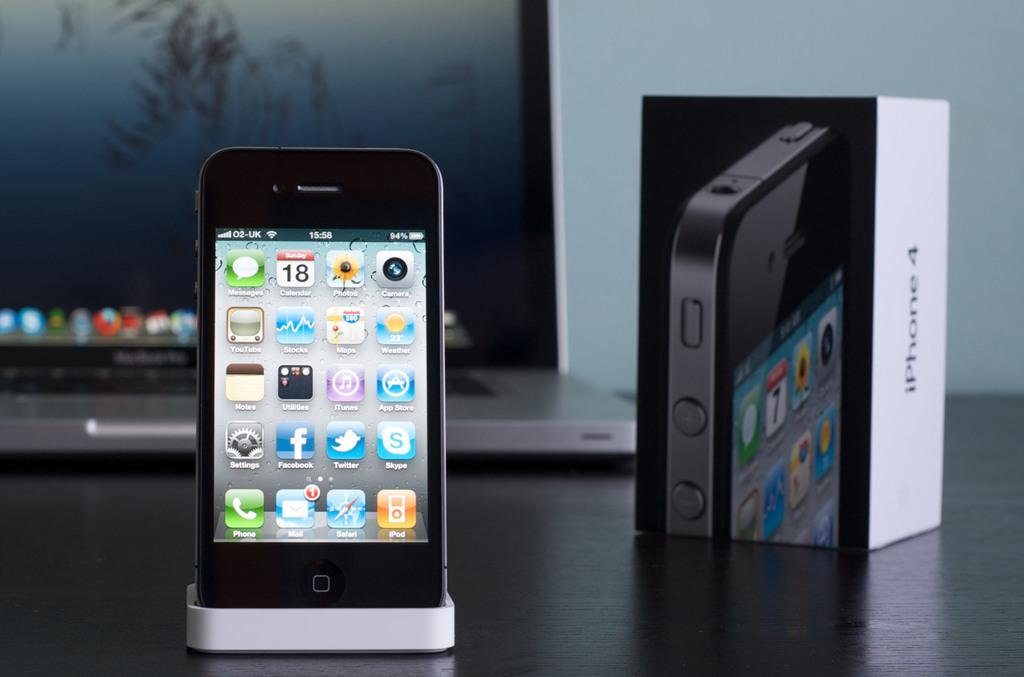<image>
Render a clear and concise summary of the photo. An iPhone 4 in a stand with many apps on screen, including YouTube, Twitter, Skype, iTunes, and Safari, next to its box 